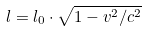<formula> <loc_0><loc_0><loc_500><loc_500>l = l _ { 0 } \cdot \sqrt { 1 - v ^ { 2 } / c ^ { 2 } }</formula> 